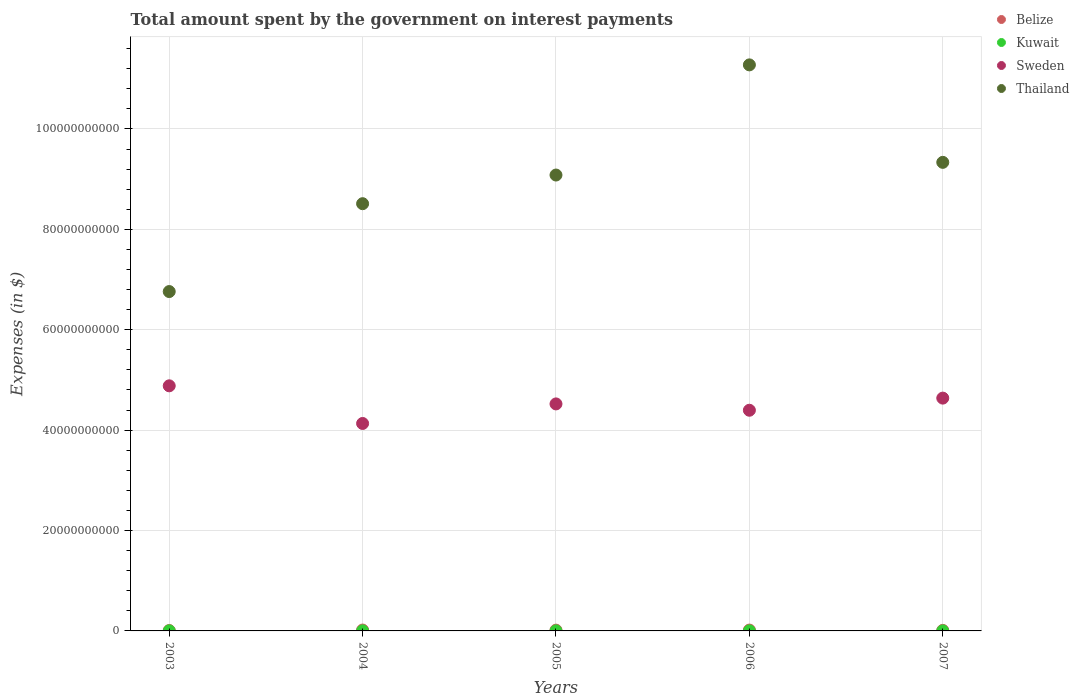What is the amount spent on interest payments by the government in Sweden in 2006?
Your response must be concise. 4.40e+1. Across all years, what is the maximum amount spent on interest payments by the government in Belize?
Your answer should be very brief. 1.76e+08. Across all years, what is the minimum amount spent on interest payments by the government in Kuwait?
Give a very brief answer. 5.00e+06. In which year was the amount spent on interest payments by the government in Kuwait maximum?
Provide a succinct answer. 2003. In which year was the amount spent on interest payments by the government in Sweden minimum?
Offer a very short reply. 2004. What is the total amount spent on interest payments by the government in Sweden in the graph?
Your answer should be compact. 2.26e+11. What is the difference between the amount spent on interest payments by the government in Sweden in 2003 and that in 2005?
Make the answer very short. 3.60e+09. What is the difference between the amount spent on interest payments by the government in Kuwait in 2005 and the amount spent on interest payments by the government in Belize in 2007?
Offer a terse response. -9.82e+07. What is the average amount spent on interest payments by the government in Thailand per year?
Your answer should be very brief. 8.99e+1. In the year 2004, what is the difference between the amount spent on interest payments by the government in Belize and amount spent on interest payments by the government in Sweden?
Provide a succinct answer. -4.12e+1. What is the ratio of the amount spent on interest payments by the government in Sweden in 2003 to that in 2006?
Keep it short and to the point. 1.11. What is the difference between the highest and the second highest amount spent on interest payments by the government in Thailand?
Offer a terse response. 1.94e+1. What is the difference between the highest and the lowest amount spent on interest payments by the government in Sweden?
Keep it short and to the point. 7.50e+09. Is it the case that in every year, the sum of the amount spent on interest payments by the government in Thailand and amount spent on interest payments by the government in Belize  is greater than the sum of amount spent on interest payments by the government in Kuwait and amount spent on interest payments by the government in Sweden?
Make the answer very short. No. Is it the case that in every year, the sum of the amount spent on interest payments by the government in Kuwait and amount spent on interest payments by the government in Belize  is greater than the amount spent on interest payments by the government in Sweden?
Keep it short and to the point. No. Is the amount spent on interest payments by the government in Kuwait strictly less than the amount spent on interest payments by the government in Belize over the years?
Keep it short and to the point. Yes. How many dotlines are there?
Provide a succinct answer. 4. Does the graph contain grids?
Offer a terse response. Yes. Where does the legend appear in the graph?
Your answer should be compact. Top right. What is the title of the graph?
Your answer should be very brief. Total amount spent by the government on interest payments. What is the label or title of the X-axis?
Provide a short and direct response. Years. What is the label or title of the Y-axis?
Offer a very short reply. Expenses (in $). What is the Expenses (in $) of Belize in 2003?
Your answer should be very brief. 8.13e+07. What is the Expenses (in $) in Kuwait in 2003?
Your answer should be very brief. 1.80e+07. What is the Expenses (in $) in Sweden in 2003?
Make the answer very short. 4.88e+1. What is the Expenses (in $) in Thailand in 2003?
Give a very brief answer. 6.76e+1. What is the Expenses (in $) in Belize in 2004?
Provide a short and direct response. 1.76e+08. What is the Expenses (in $) of Kuwait in 2004?
Provide a short and direct response. 1.30e+07. What is the Expenses (in $) in Sweden in 2004?
Offer a very short reply. 4.13e+1. What is the Expenses (in $) in Thailand in 2004?
Make the answer very short. 8.51e+1. What is the Expenses (in $) in Belize in 2005?
Your response must be concise. 1.54e+08. What is the Expenses (in $) of Kuwait in 2005?
Ensure brevity in your answer.  1.30e+07. What is the Expenses (in $) in Sweden in 2005?
Ensure brevity in your answer.  4.52e+1. What is the Expenses (in $) of Thailand in 2005?
Offer a terse response. 9.08e+1. What is the Expenses (in $) of Belize in 2006?
Your response must be concise. 1.70e+08. What is the Expenses (in $) of Kuwait in 2006?
Your answer should be very brief. 1.30e+07. What is the Expenses (in $) in Sweden in 2006?
Your response must be concise. 4.40e+1. What is the Expenses (in $) of Thailand in 2006?
Make the answer very short. 1.13e+11. What is the Expenses (in $) in Belize in 2007?
Provide a short and direct response. 1.11e+08. What is the Expenses (in $) of Sweden in 2007?
Provide a short and direct response. 4.64e+1. What is the Expenses (in $) of Thailand in 2007?
Your response must be concise. 9.33e+1. Across all years, what is the maximum Expenses (in $) in Belize?
Offer a terse response. 1.76e+08. Across all years, what is the maximum Expenses (in $) of Kuwait?
Offer a very short reply. 1.80e+07. Across all years, what is the maximum Expenses (in $) in Sweden?
Offer a terse response. 4.88e+1. Across all years, what is the maximum Expenses (in $) in Thailand?
Make the answer very short. 1.13e+11. Across all years, what is the minimum Expenses (in $) in Belize?
Give a very brief answer. 8.13e+07. Across all years, what is the minimum Expenses (in $) in Sweden?
Your answer should be very brief. 4.13e+1. Across all years, what is the minimum Expenses (in $) in Thailand?
Provide a short and direct response. 6.76e+1. What is the total Expenses (in $) in Belize in the graph?
Offer a very short reply. 6.92e+08. What is the total Expenses (in $) of Kuwait in the graph?
Provide a succinct answer. 6.20e+07. What is the total Expenses (in $) of Sweden in the graph?
Offer a very short reply. 2.26e+11. What is the total Expenses (in $) of Thailand in the graph?
Keep it short and to the point. 4.50e+11. What is the difference between the Expenses (in $) of Belize in 2003 and that in 2004?
Your answer should be compact. -9.45e+07. What is the difference between the Expenses (in $) in Kuwait in 2003 and that in 2004?
Keep it short and to the point. 5.00e+06. What is the difference between the Expenses (in $) in Sweden in 2003 and that in 2004?
Your answer should be compact. 7.50e+09. What is the difference between the Expenses (in $) of Thailand in 2003 and that in 2004?
Make the answer very short. -1.75e+1. What is the difference between the Expenses (in $) of Belize in 2003 and that in 2005?
Make the answer very short. -7.24e+07. What is the difference between the Expenses (in $) of Kuwait in 2003 and that in 2005?
Ensure brevity in your answer.  5.00e+06. What is the difference between the Expenses (in $) of Sweden in 2003 and that in 2005?
Your answer should be compact. 3.60e+09. What is the difference between the Expenses (in $) in Thailand in 2003 and that in 2005?
Keep it short and to the point. -2.32e+1. What is the difference between the Expenses (in $) of Belize in 2003 and that in 2006?
Offer a terse response. -8.89e+07. What is the difference between the Expenses (in $) of Kuwait in 2003 and that in 2006?
Provide a succinct answer. 5.00e+06. What is the difference between the Expenses (in $) of Sweden in 2003 and that in 2006?
Offer a very short reply. 4.87e+09. What is the difference between the Expenses (in $) in Thailand in 2003 and that in 2006?
Your answer should be compact. -4.52e+1. What is the difference between the Expenses (in $) in Belize in 2003 and that in 2007?
Your answer should be very brief. -2.99e+07. What is the difference between the Expenses (in $) in Kuwait in 2003 and that in 2007?
Your response must be concise. 1.30e+07. What is the difference between the Expenses (in $) of Sweden in 2003 and that in 2007?
Your answer should be very brief. 2.45e+09. What is the difference between the Expenses (in $) of Thailand in 2003 and that in 2007?
Your answer should be compact. -2.57e+1. What is the difference between the Expenses (in $) in Belize in 2004 and that in 2005?
Make the answer very short. 2.21e+07. What is the difference between the Expenses (in $) of Kuwait in 2004 and that in 2005?
Ensure brevity in your answer.  0. What is the difference between the Expenses (in $) in Sweden in 2004 and that in 2005?
Make the answer very short. -3.90e+09. What is the difference between the Expenses (in $) in Thailand in 2004 and that in 2005?
Keep it short and to the point. -5.71e+09. What is the difference between the Expenses (in $) of Belize in 2004 and that in 2006?
Offer a terse response. 5.65e+06. What is the difference between the Expenses (in $) in Sweden in 2004 and that in 2006?
Offer a terse response. -2.63e+09. What is the difference between the Expenses (in $) in Thailand in 2004 and that in 2006?
Give a very brief answer. -2.77e+1. What is the difference between the Expenses (in $) of Belize in 2004 and that in 2007?
Offer a very short reply. 6.47e+07. What is the difference between the Expenses (in $) in Sweden in 2004 and that in 2007?
Ensure brevity in your answer.  -5.05e+09. What is the difference between the Expenses (in $) of Thailand in 2004 and that in 2007?
Your answer should be very brief. -8.24e+09. What is the difference between the Expenses (in $) in Belize in 2005 and that in 2006?
Provide a succinct answer. -1.65e+07. What is the difference between the Expenses (in $) in Sweden in 2005 and that in 2006?
Your answer should be compact. 1.26e+09. What is the difference between the Expenses (in $) in Thailand in 2005 and that in 2006?
Keep it short and to the point. -2.19e+1. What is the difference between the Expenses (in $) of Belize in 2005 and that in 2007?
Keep it short and to the point. 4.26e+07. What is the difference between the Expenses (in $) of Kuwait in 2005 and that in 2007?
Provide a short and direct response. 8.00e+06. What is the difference between the Expenses (in $) in Sweden in 2005 and that in 2007?
Offer a terse response. -1.16e+09. What is the difference between the Expenses (in $) of Thailand in 2005 and that in 2007?
Offer a very short reply. -2.53e+09. What is the difference between the Expenses (in $) in Belize in 2006 and that in 2007?
Your response must be concise. 5.90e+07. What is the difference between the Expenses (in $) of Kuwait in 2006 and that in 2007?
Ensure brevity in your answer.  8.00e+06. What is the difference between the Expenses (in $) in Sweden in 2006 and that in 2007?
Provide a succinct answer. -2.42e+09. What is the difference between the Expenses (in $) of Thailand in 2006 and that in 2007?
Your response must be concise. 1.94e+1. What is the difference between the Expenses (in $) in Belize in 2003 and the Expenses (in $) in Kuwait in 2004?
Your answer should be very brief. 6.83e+07. What is the difference between the Expenses (in $) of Belize in 2003 and the Expenses (in $) of Sweden in 2004?
Your answer should be compact. -4.12e+1. What is the difference between the Expenses (in $) of Belize in 2003 and the Expenses (in $) of Thailand in 2004?
Provide a short and direct response. -8.50e+1. What is the difference between the Expenses (in $) of Kuwait in 2003 and the Expenses (in $) of Sweden in 2004?
Ensure brevity in your answer.  -4.13e+1. What is the difference between the Expenses (in $) of Kuwait in 2003 and the Expenses (in $) of Thailand in 2004?
Provide a short and direct response. -8.51e+1. What is the difference between the Expenses (in $) in Sweden in 2003 and the Expenses (in $) in Thailand in 2004?
Your answer should be very brief. -3.63e+1. What is the difference between the Expenses (in $) in Belize in 2003 and the Expenses (in $) in Kuwait in 2005?
Provide a succinct answer. 6.83e+07. What is the difference between the Expenses (in $) in Belize in 2003 and the Expenses (in $) in Sweden in 2005?
Provide a succinct answer. -4.51e+1. What is the difference between the Expenses (in $) in Belize in 2003 and the Expenses (in $) in Thailand in 2005?
Give a very brief answer. -9.07e+1. What is the difference between the Expenses (in $) of Kuwait in 2003 and the Expenses (in $) of Sweden in 2005?
Ensure brevity in your answer.  -4.52e+1. What is the difference between the Expenses (in $) of Kuwait in 2003 and the Expenses (in $) of Thailand in 2005?
Keep it short and to the point. -9.08e+1. What is the difference between the Expenses (in $) of Sweden in 2003 and the Expenses (in $) of Thailand in 2005?
Give a very brief answer. -4.20e+1. What is the difference between the Expenses (in $) of Belize in 2003 and the Expenses (in $) of Kuwait in 2006?
Your answer should be very brief. 6.83e+07. What is the difference between the Expenses (in $) of Belize in 2003 and the Expenses (in $) of Sweden in 2006?
Ensure brevity in your answer.  -4.39e+1. What is the difference between the Expenses (in $) in Belize in 2003 and the Expenses (in $) in Thailand in 2006?
Your answer should be compact. -1.13e+11. What is the difference between the Expenses (in $) in Kuwait in 2003 and the Expenses (in $) in Sweden in 2006?
Your answer should be very brief. -4.39e+1. What is the difference between the Expenses (in $) in Kuwait in 2003 and the Expenses (in $) in Thailand in 2006?
Give a very brief answer. -1.13e+11. What is the difference between the Expenses (in $) in Sweden in 2003 and the Expenses (in $) in Thailand in 2006?
Make the answer very short. -6.39e+1. What is the difference between the Expenses (in $) in Belize in 2003 and the Expenses (in $) in Kuwait in 2007?
Offer a very short reply. 7.63e+07. What is the difference between the Expenses (in $) in Belize in 2003 and the Expenses (in $) in Sweden in 2007?
Keep it short and to the point. -4.63e+1. What is the difference between the Expenses (in $) in Belize in 2003 and the Expenses (in $) in Thailand in 2007?
Provide a succinct answer. -9.33e+1. What is the difference between the Expenses (in $) of Kuwait in 2003 and the Expenses (in $) of Sweden in 2007?
Make the answer very short. -4.64e+1. What is the difference between the Expenses (in $) in Kuwait in 2003 and the Expenses (in $) in Thailand in 2007?
Give a very brief answer. -9.33e+1. What is the difference between the Expenses (in $) of Sweden in 2003 and the Expenses (in $) of Thailand in 2007?
Provide a short and direct response. -4.45e+1. What is the difference between the Expenses (in $) of Belize in 2004 and the Expenses (in $) of Kuwait in 2005?
Your answer should be very brief. 1.63e+08. What is the difference between the Expenses (in $) of Belize in 2004 and the Expenses (in $) of Sweden in 2005?
Provide a succinct answer. -4.50e+1. What is the difference between the Expenses (in $) in Belize in 2004 and the Expenses (in $) in Thailand in 2005?
Provide a short and direct response. -9.06e+1. What is the difference between the Expenses (in $) in Kuwait in 2004 and the Expenses (in $) in Sweden in 2005?
Offer a terse response. -4.52e+1. What is the difference between the Expenses (in $) of Kuwait in 2004 and the Expenses (in $) of Thailand in 2005?
Ensure brevity in your answer.  -9.08e+1. What is the difference between the Expenses (in $) in Sweden in 2004 and the Expenses (in $) in Thailand in 2005?
Your answer should be compact. -4.95e+1. What is the difference between the Expenses (in $) of Belize in 2004 and the Expenses (in $) of Kuwait in 2006?
Your answer should be compact. 1.63e+08. What is the difference between the Expenses (in $) in Belize in 2004 and the Expenses (in $) in Sweden in 2006?
Provide a succinct answer. -4.38e+1. What is the difference between the Expenses (in $) of Belize in 2004 and the Expenses (in $) of Thailand in 2006?
Your answer should be compact. -1.13e+11. What is the difference between the Expenses (in $) of Kuwait in 2004 and the Expenses (in $) of Sweden in 2006?
Your answer should be very brief. -4.39e+1. What is the difference between the Expenses (in $) of Kuwait in 2004 and the Expenses (in $) of Thailand in 2006?
Your answer should be very brief. -1.13e+11. What is the difference between the Expenses (in $) in Sweden in 2004 and the Expenses (in $) in Thailand in 2006?
Ensure brevity in your answer.  -7.14e+1. What is the difference between the Expenses (in $) in Belize in 2004 and the Expenses (in $) in Kuwait in 2007?
Offer a very short reply. 1.71e+08. What is the difference between the Expenses (in $) in Belize in 2004 and the Expenses (in $) in Sweden in 2007?
Offer a terse response. -4.62e+1. What is the difference between the Expenses (in $) of Belize in 2004 and the Expenses (in $) of Thailand in 2007?
Keep it short and to the point. -9.32e+1. What is the difference between the Expenses (in $) in Kuwait in 2004 and the Expenses (in $) in Sweden in 2007?
Provide a succinct answer. -4.64e+1. What is the difference between the Expenses (in $) in Kuwait in 2004 and the Expenses (in $) in Thailand in 2007?
Your answer should be very brief. -9.33e+1. What is the difference between the Expenses (in $) in Sweden in 2004 and the Expenses (in $) in Thailand in 2007?
Your answer should be compact. -5.20e+1. What is the difference between the Expenses (in $) in Belize in 2005 and the Expenses (in $) in Kuwait in 2006?
Keep it short and to the point. 1.41e+08. What is the difference between the Expenses (in $) in Belize in 2005 and the Expenses (in $) in Sweden in 2006?
Provide a succinct answer. -4.38e+1. What is the difference between the Expenses (in $) of Belize in 2005 and the Expenses (in $) of Thailand in 2006?
Offer a terse response. -1.13e+11. What is the difference between the Expenses (in $) in Kuwait in 2005 and the Expenses (in $) in Sweden in 2006?
Keep it short and to the point. -4.39e+1. What is the difference between the Expenses (in $) in Kuwait in 2005 and the Expenses (in $) in Thailand in 2006?
Offer a terse response. -1.13e+11. What is the difference between the Expenses (in $) of Sweden in 2005 and the Expenses (in $) of Thailand in 2006?
Make the answer very short. -6.75e+1. What is the difference between the Expenses (in $) of Belize in 2005 and the Expenses (in $) of Kuwait in 2007?
Make the answer very short. 1.49e+08. What is the difference between the Expenses (in $) in Belize in 2005 and the Expenses (in $) in Sweden in 2007?
Provide a succinct answer. -4.62e+1. What is the difference between the Expenses (in $) of Belize in 2005 and the Expenses (in $) of Thailand in 2007?
Offer a very short reply. -9.32e+1. What is the difference between the Expenses (in $) in Kuwait in 2005 and the Expenses (in $) in Sweden in 2007?
Offer a terse response. -4.64e+1. What is the difference between the Expenses (in $) of Kuwait in 2005 and the Expenses (in $) of Thailand in 2007?
Your answer should be compact. -9.33e+1. What is the difference between the Expenses (in $) of Sweden in 2005 and the Expenses (in $) of Thailand in 2007?
Give a very brief answer. -4.81e+1. What is the difference between the Expenses (in $) of Belize in 2006 and the Expenses (in $) of Kuwait in 2007?
Ensure brevity in your answer.  1.65e+08. What is the difference between the Expenses (in $) in Belize in 2006 and the Expenses (in $) in Sweden in 2007?
Your response must be concise. -4.62e+1. What is the difference between the Expenses (in $) in Belize in 2006 and the Expenses (in $) in Thailand in 2007?
Your answer should be compact. -9.32e+1. What is the difference between the Expenses (in $) of Kuwait in 2006 and the Expenses (in $) of Sweden in 2007?
Make the answer very short. -4.64e+1. What is the difference between the Expenses (in $) in Kuwait in 2006 and the Expenses (in $) in Thailand in 2007?
Your answer should be very brief. -9.33e+1. What is the difference between the Expenses (in $) in Sweden in 2006 and the Expenses (in $) in Thailand in 2007?
Provide a short and direct response. -4.94e+1. What is the average Expenses (in $) in Belize per year?
Offer a terse response. 1.38e+08. What is the average Expenses (in $) of Kuwait per year?
Offer a terse response. 1.24e+07. What is the average Expenses (in $) of Sweden per year?
Provide a short and direct response. 4.51e+1. What is the average Expenses (in $) in Thailand per year?
Your answer should be compact. 8.99e+1. In the year 2003, what is the difference between the Expenses (in $) of Belize and Expenses (in $) of Kuwait?
Ensure brevity in your answer.  6.33e+07. In the year 2003, what is the difference between the Expenses (in $) in Belize and Expenses (in $) in Sweden?
Offer a terse response. -4.87e+1. In the year 2003, what is the difference between the Expenses (in $) of Belize and Expenses (in $) of Thailand?
Your answer should be compact. -6.75e+1. In the year 2003, what is the difference between the Expenses (in $) of Kuwait and Expenses (in $) of Sweden?
Give a very brief answer. -4.88e+1. In the year 2003, what is the difference between the Expenses (in $) in Kuwait and Expenses (in $) in Thailand?
Your response must be concise. -6.76e+1. In the year 2003, what is the difference between the Expenses (in $) in Sweden and Expenses (in $) in Thailand?
Provide a short and direct response. -1.88e+1. In the year 2004, what is the difference between the Expenses (in $) in Belize and Expenses (in $) in Kuwait?
Make the answer very short. 1.63e+08. In the year 2004, what is the difference between the Expenses (in $) of Belize and Expenses (in $) of Sweden?
Ensure brevity in your answer.  -4.12e+1. In the year 2004, what is the difference between the Expenses (in $) in Belize and Expenses (in $) in Thailand?
Keep it short and to the point. -8.49e+1. In the year 2004, what is the difference between the Expenses (in $) of Kuwait and Expenses (in $) of Sweden?
Ensure brevity in your answer.  -4.13e+1. In the year 2004, what is the difference between the Expenses (in $) of Kuwait and Expenses (in $) of Thailand?
Your answer should be compact. -8.51e+1. In the year 2004, what is the difference between the Expenses (in $) of Sweden and Expenses (in $) of Thailand?
Offer a very short reply. -4.38e+1. In the year 2005, what is the difference between the Expenses (in $) of Belize and Expenses (in $) of Kuwait?
Give a very brief answer. 1.41e+08. In the year 2005, what is the difference between the Expenses (in $) of Belize and Expenses (in $) of Sweden?
Offer a terse response. -4.51e+1. In the year 2005, what is the difference between the Expenses (in $) of Belize and Expenses (in $) of Thailand?
Provide a succinct answer. -9.07e+1. In the year 2005, what is the difference between the Expenses (in $) in Kuwait and Expenses (in $) in Sweden?
Offer a very short reply. -4.52e+1. In the year 2005, what is the difference between the Expenses (in $) of Kuwait and Expenses (in $) of Thailand?
Provide a short and direct response. -9.08e+1. In the year 2005, what is the difference between the Expenses (in $) of Sweden and Expenses (in $) of Thailand?
Ensure brevity in your answer.  -4.56e+1. In the year 2006, what is the difference between the Expenses (in $) in Belize and Expenses (in $) in Kuwait?
Offer a terse response. 1.57e+08. In the year 2006, what is the difference between the Expenses (in $) of Belize and Expenses (in $) of Sweden?
Ensure brevity in your answer.  -4.38e+1. In the year 2006, what is the difference between the Expenses (in $) in Belize and Expenses (in $) in Thailand?
Keep it short and to the point. -1.13e+11. In the year 2006, what is the difference between the Expenses (in $) in Kuwait and Expenses (in $) in Sweden?
Keep it short and to the point. -4.39e+1. In the year 2006, what is the difference between the Expenses (in $) of Kuwait and Expenses (in $) of Thailand?
Keep it short and to the point. -1.13e+11. In the year 2006, what is the difference between the Expenses (in $) in Sweden and Expenses (in $) in Thailand?
Offer a very short reply. -6.88e+1. In the year 2007, what is the difference between the Expenses (in $) in Belize and Expenses (in $) in Kuwait?
Provide a succinct answer. 1.06e+08. In the year 2007, what is the difference between the Expenses (in $) of Belize and Expenses (in $) of Sweden?
Ensure brevity in your answer.  -4.63e+1. In the year 2007, what is the difference between the Expenses (in $) of Belize and Expenses (in $) of Thailand?
Offer a terse response. -9.32e+1. In the year 2007, what is the difference between the Expenses (in $) of Kuwait and Expenses (in $) of Sweden?
Keep it short and to the point. -4.64e+1. In the year 2007, what is the difference between the Expenses (in $) of Kuwait and Expenses (in $) of Thailand?
Offer a very short reply. -9.33e+1. In the year 2007, what is the difference between the Expenses (in $) in Sweden and Expenses (in $) in Thailand?
Offer a very short reply. -4.70e+1. What is the ratio of the Expenses (in $) of Belize in 2003 to that in 2004?
Offer a terse response. 0.46. What is the ratio of the Expenses (in $) of Kuwait in 2003 to that in 2004?
Provide a short and direct response. 1.38. What is the ratio of the Expenses (in $) in Sweden in 2003 to that in 2004?
Your response must be concise. 1.18. What is the ratio of the Expenses (in $) of Thailand in 2003 to that in 2004?
Give a very brief answer. 0.79. What is the ratio of the Expenses (in $) of Belize in 2003 to that in 2005?
Give a very brief answer. 0.53. What is the ratio of the Expenses (in $) of Kuwait in 2003 to that in 2005?
Your response must be concise. 1.38. What is the ratio of the Expenses (in $) in Sweden in 2003 to that in 2005?
Your answer should be compact. 1.08. What is the ratio of the Expenses (in $) in Thailand in 2003 to that in 2005?
Offer a terse response. 0.74. What is the ratio of the Expenses (in $) of Belize in 2003 to that in 2006?
Give a very brief answer. 0.48. What is the ratio of the Expenses (in $) in Kuwait in 2003 to that in 2006?
Your response must be concise. 1.38. What is the ratio of the Expenses (in $) of Sweden in 2003 to that in 2006?
Your answer should be very brief. 1.11. What is the ratio of the Expenses (in $) in Thailand in 2003 to that in 2006?
Provide a succinct answer. 0.6. What is the ratio of the Expenses (in $) of Belize in 2003 to that in 2007?
Offer a terse response. 0.73. What is the ratio of the Expenses (in $) in Kuwait in 2003 to that in 2007?
Provide a short and direct response. 3.6. What is the ratio of the Expenses (in $) in Sweden in 2003 to that in 2007?
Offer a terse response. 1.05. What is the ratio of the Expenses (in $) of Thailand in 2003 to that in 2007?
Your answer should be compact. 0.72. What is the ratio of the Expenses (in $) of Belize in 2004 to that in 2005?
Make the answer very short. 1.14. What is the ratio of the Expenses (in $) of Sweden in 2004 to that in 2005?
Keep it short and to the point. 0.91. What is the ratio of the Expenses (in $) in Thailand in 2004 to that in 2005?
Offer a terse response. 0.94. What is the ratio of the Expenses (in $) in Belize in 2004 to that in 2006?
Your answer should be very brief. 1.03. What is the ratio of the Expenses (in $) in Kuwait in 2004 to that in 2006?
Your answer should be very brief. 1. What is the ratio of the Expenses (in $) of Sweden in 2004 to that in 2006?
Keep it short and to the point. 0.94. What is the ratio of the Expenses (in $) in Thailand in 2004 to that in 2006?
Keep it short and to the point. 0.75. What is the ratio of the Expenses (in $) in Belize in 2004 to that in 2007?
Keep it short and to the point. 1.58. What is the ratio of the Expenses (in $) of Sweden in 2004 to that in 2007?
Your response must be concise. 0.89. What is the ratio of the Expenses (in $) of Thailand in 2004 to that in 2007?
Give a very brief answer. 0.91. What is the ratio of the Expenses (in $) in Belize in 2005 to that in 2006?
Keep it short and to the point. 0.9. What is the ratio of the Expenses (in $) in Sweden in 2005 to that in 2006?
Provide a short and direct response. 1.03. What is the ratio of the Expenses (in $) of Thailand in 2005 to that in 2006?
Make the answer very short. 0.81. What is the ratio of the Expenses (in $) of Belize in 2005 to that in 2007?
Your answer should be very brief. 1.38. What is the ratio of the Expenses (in $) in Kuwait in 2005 to that in 2007?
Provide a succinct answer. 2.6. What is the ratio of the Expenses (in $) of Sweden in 2005 to that in 2007?
Your answer should be compact. 0.98. What is the ratio of the Expenses (in $) of Thailand in 2005 to that in 2007?
Your response must be concise. 0.97. What is the ratio of the Expenses (in $) in Belize in 2006 to that in 2007?
Provide a succinct answer. 1.53. What is the ratio of the Expenses (in $) of Sweden in 2006 to that in 2007?
Offer a terse response. 0.95. What is the ratio of the Expenses (in $) of Thailand in 2006 to that in 2007?
Offer a terse response. 1.21. What is the difference between the highest and the second highest Expenses (in $) in Belize?
Give a very brief answer. 5.65e+06. What is the difference between the highest and the second highest Expenses (in $) of Sweden?
Provide a succinct answer. 2.45e+09. What is the difference between the highest and the second highest Expenses (in $) in Thailand?
Make the answer very short. 1.94e+1. What is the difference between the highest and the lowest Expenses (in $) of Belize?
Your answer should be compact. 9.45e+07. What is the difference between the highest and the lowest Expenses (in $) of Kuwait?
Your response must be concise. 1.30e+07. What is the difference between the highest and the lowest Expenses (in $) of Sweden?
Make the answer very short. 7.50e+09. What is the difference between the highest and the lowest Expenses (in $) in Thailand?
Provide a short and direct response. 4.52e+1. 